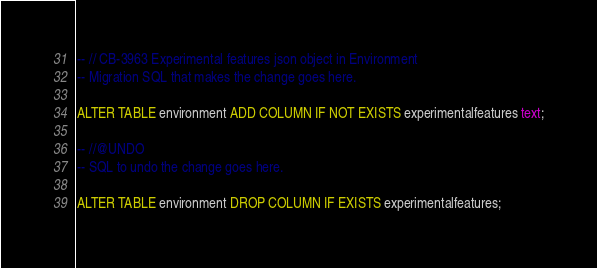<code> <loc_0><loc_0><loc_500><loc_500><_SQL_>-- // CB-3963 Experimental features json object in Environment
-- Migration SQL that makes the change goes here.

ALTER TABLE environment ADD COLUMN IF NOT EXISTS experimentalfeatures text;

-- //@UNDO
-- SQL to undo the change goes here.

ALTER TABLE environment DROP COLUMN IF EXISTS experimentalfeatures;
</code> 